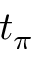Convert formula to latex. <formula><loc_0><loc_0><loc_500><loc_500>t _ { \pi }</formula> 